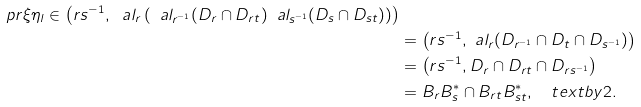<formula> <loc_0><loc_0><loc_500><loc_500>\ p r { \xi } { \eta } _ { l } \in \left ( r s ^ { - 1 } , \ a l _ { r } \left ( \ a l _ { r ^ { - 1 } } ( D _ { r } \cap D _ { r t } ) \ a l _ { s ^ { - 1 } } ( D _ { s } \cap D _ { s t } ) \right ) \right ) \\ & = \left ( r s ^ { - 1 } , \ a l _ { r } ( D _ { r ^ { - 1 } } \cap D _ { t } \cap D _ { s ^ { - 1 } } ) \right ) \\ & = \left ( r s ^ { - 1 } , D _ { r } \cap D _ { r t } \cap D _ { r s ^ { - 1 } } \right ) \\ & = B _ { r } B _ { s } ^ { * } \cap B _ { r t } B _ { s t } ^ { * } , \quad t e x t { b y 2 . }</formula> 